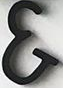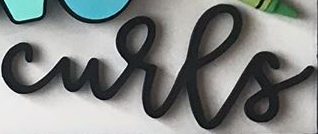Read the text from these images in sequence, separated by a semicolon. &; curls 